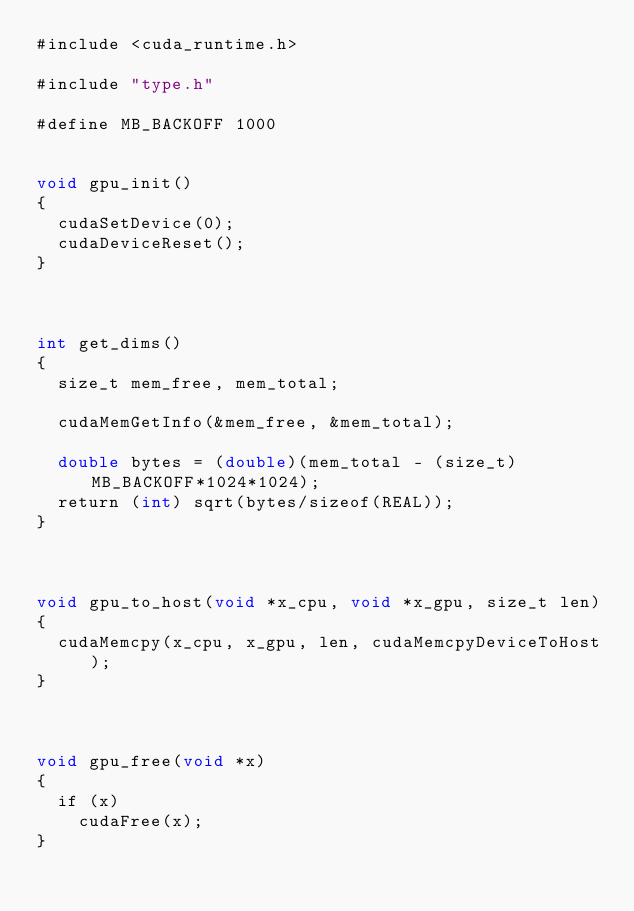<code> <loc_0><loc_0><loc_500><loc_500><_Cuda_>#include <cuda_runtime.h>

#include "type.h"

#define MB_BACKOFF 1000


void gpu_init()
{
  cudaSetDevice(0);
  cudaDeviceReset();
}



int get_dims()
{
  size_t mem_free, mem_total;
  
  cudaMemGetInfo(&mem_free, &mem_total);
  
  double bytes = (double)(mem_total - (size_t)MB_BACKOFF*1024*1024);
  return (int) sqrt(bytes/sizeof(REAL));
}



void gpu_to_host(void *x_cpu, void *x_gpu, size_t len)
{
  cudaMemcpy(x_cpu, x_gpu, len, cudaMemcpyDeviceToHost);
}



void gpu_free(void *x)
{
  if (x)
    cudaFree(x);
}
</code> 